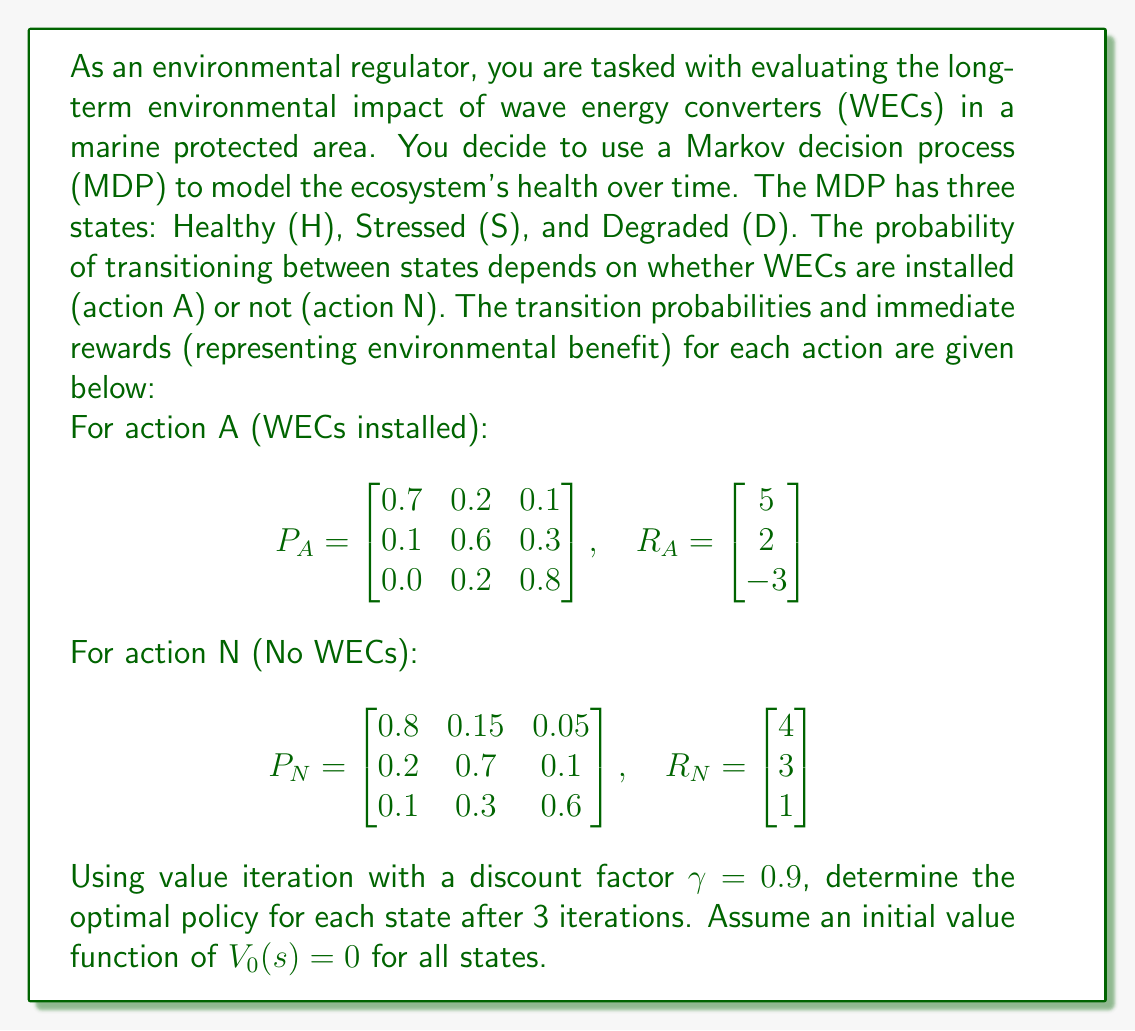Give your solution to this math problem. To solve this problem, we'll use the value iteration algorithm for 3 iterations. The value function update equation is:

$$V_{k+1}(s) = \max_{a \in \{A,N\}} \left(R_a(s) + \gamma \sum_{s'} P_a(s,s') V_k(s')\right)$$

Where $V_k(s)$ is the value function for state $s$ at iteration $k$, $R_a(s)$ is the immediate reward for action $a$ in state $s$, and $P_a(s,s')$ is the transition probability from state $s$ to $s'$ under action $a$.

Let's perform the iterations:

Iteration 1:
For state H:
$$V_1(H) = \max\begin{cases}
5 + 0.9(0.7 \cdot 0 + 0.2 \cdot 0 + 0.1 \cdot 0) = 5 \quad \text{(A)}\\
4 + 0.9(0.8 \cdot 0 + 0.15 \cdot 0 + 0.05 \cdot 0) = 4 \quad \text{(N)}
\end{cases}$$

For state S:
$$V_1(S) = \max\begin{cases}
2 + 0.9(0.1 \cdot 0 + 0.6 \cdot 0 + 0.3 \cdot 0) = 2 \quad \text{(A)}\\
3 + 0.9(0.2 \cdot 0 + 0.7 \cdot 0 + 0.1 \cdot 0) = 3 \quad \text{(N)}
\end{cases}$$

For state D:
$$V_1(D) = \max\begin{cases}
-3 + 0.9(0.0 \cdot 0 + 0.2 \cdot 0 + 0.8 \cdot 0) = -3 \quad \text{(A)}\\
1 + 0.9(0.1 \cdot 0 + 0.3 \cdot 0 + 0.6 \cdot 0) = 1 \quad \text{(N)}
\end{cases}$$

After iteration 1: $V_1 = [5, 3, 1]$, Policy = [A, N, N]

Iteration 2:
For state H:
$$V_2(H) = \max\begin{cases}
5 + 0.9(0.7 \cdot 5 + 0.2 \cdot 3 + 0.1 \cdot 1) = 9.02 \quad \text{(A)}\\
4 + 0.9(0.8 \cdot 5 + 0.15 \cdot 3 + 0.05 \cdot 1) = 8.41 \quad \text{(N)}
\end{cases}$$

For state S:
$$V_2(S) = \max\begin{cases}
2 + 0.9(0.1 \cdot 5 + 0.6 \cdot 3 + 0.3 \cdot 1) = 4.32 \quad \text{(A)}\\
3 + 0.9(0.2 \cdot 5 + 0.7 \cdot 3 + 0.1 \cdot 1) = 5.67 \quad \text{(N)}
\end{cases}$$

For state D:
$$V_2(D) = \max\begin{cases}
-3 + 0.9(0.0 \cdot 5 + 0.2 \cdot 3 + 0.8 \cdot 1) = -2.16 \quad \text{(A)}\\
1 + 0.9(0.1 \cdot 5 + 0.3 \cdot 3 + 0.6 \cdot 1) = 2.97 \quad \text{(N)}
\end{cases}$$

After iteration 2: $V_2 = [9.02, 5.67, 2.97]$, Policy = [A, N, N]

Iteration 3:
For state H:
$$V_3(H) = \max\begin{cases}
5 + 0.9(0.7 \cdot 9.02 + 0.2 \cdot 5.67 + 0.1 \cdot 2.97) = 12.1866 \quad \text{(A)}\\
4 + 0.9(0.8 \cdot 9.02 + 0.15 \cdot 5.67 + 0.05 \cdot 2.97) = 11.5791 \quad \text{(N)}
\end{cases}$$

For state S:
$$V_3(S) = \max\begin{cases}
2 + 0.9(0.1 \cdot 9.02 + 0.6 \cdot 5.67 + 0.3 \cdot 2.97) = 6.8487 \quad \text{(A)}\\
3 + 0.9(0.2 \cdot 9.02 + 0.7 \cdot 5.67 + 0.1 \cdot 2.97) = 8.3871 \quad \text{(N)}
\end{cases}$$

For state D:
$$V_3(D) = \max\begin{cases}
-3 + 0.9(0.0 \cdot 9.02 + 0.2 \cdot 5.67 + 0.8 \cdot 2.97) = -0.2694 \quad \text{(A)}\\
1 + 0.9(0.1 \cdot 9.02 + 0.3 \cdot 5.67 + 0.6 \cdot 2.97) = 4.6761 \quad \text{(N)}
\end{cases}$$

After iteration 3: $V_3 = [12.1866, 8.3871, 4.6761]$, Policy = [A, N, N]
Answer: The optimal policy after 3 iterations of value iteration is:
- For state H (Healthy): Install WECs (Action A)
- For state S (Stressed): Do not install WECs (Action N)
- For state D (Degraded): Do not install WECs (Action N) 